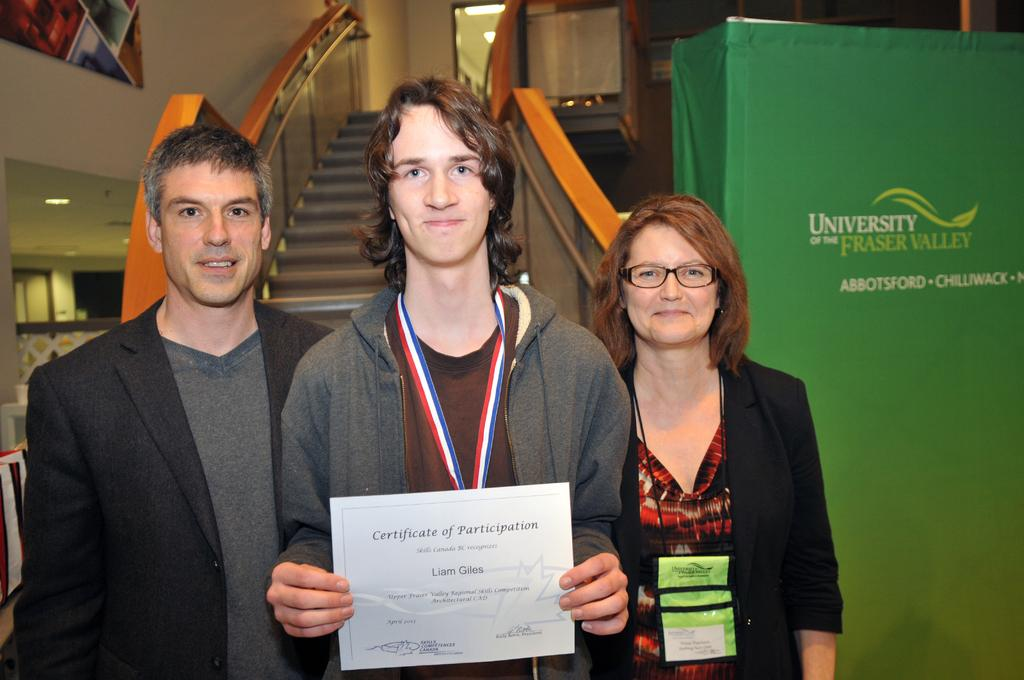Provide a one-sentence caption for the provided image. Boy holding a Certificate of Participation posing with his parents. 